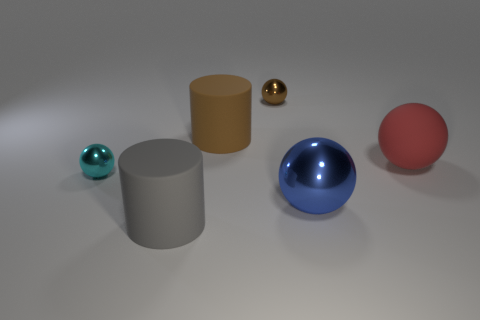Subtract 1 spheres. How many spheres are left? 3 Subtract all gray balls. Subtract all yellow blocks. How many balls are left? 4 Add 4 large spheres. How many objects exist? 10 Subtract all balls. How many objects are left? 2 Subtract all metallic blocks. Subtract all large red matte spheres. How many objects are left? 5 Add 2 small metal objects. How many small metal objects are left? 4 Add 1 blue metallic balls. How many blue metallic balls exist? 2 Subtract 0 yellow cubes. How many objects are left? 6 